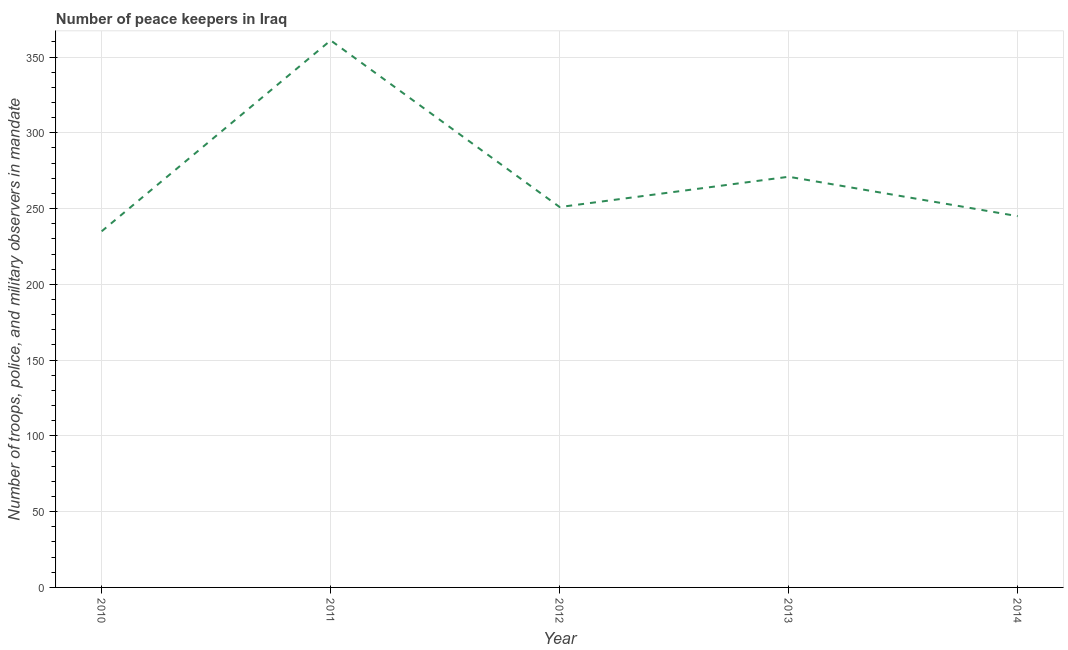What is the number of peace keepers in 2012?
Offer a terse response. 251. Across all years, what is the maximum number of peace keepers?
Give a very brief answer. 361. Across all years, what is the minimum number of peace keepers?
Give a very brief answer. 235. In which year was the number of peace keepers minimum?
Provide a succinct answer. 2010. What is the sum of the number of peace keepers?
Offer a very short reply. 1363. What is the difference between the number of peace keepers in 2011 and 2014?
Give a very brief answer. 116. What is the average number of peace keepers per year?
Your answer should be compact. 272.6. What is the median number of peace keepers?
Provide a succinct answer. 251. In how many years, is the number of peace keepers greater than 110 ?
Offer a very short reply. 5. Do a majority of the years between 2011 and 2014 (inclusive) have number of peace keepers greater than 130 ?
Your answer should be very brief. Yes. What is the ratio of the number of peace keepers in 2011 to that in 2013?
Ensure brevity in your answer.  1.33. Is the number of peace keepers in 2010 less than that in 2011?
Offer a terse response. Yes. Is the sum of the number of peace keepers in 2011 and 2013 greater than the maximum number of peace keepers across all years?
Your response must be concise. Yes. What is the difference between the highest and the lowest number of peace keepers?
Provide a succinct answer. 126. How many years are there in the graph?
Offer a very short reply. 5. Does the graph contain any zero values?
Ensure brevity in your answer.  No. Does the graph contain grids?
Offer a very short reply. Yes. What is the title of the graph?
Your answer should be very brief. Number of peace keepers in Iraq. What is the label or title of the Y-axis?
Your response must be concise. Number of troops, police, and military observers in mandate. What is the Number of troops, police, and military observers in mandate of 2010?
Offer a very short reply. 235. What is the Number of troops, police, and military observers in mandate in 2011?
Ensure brevity in your answer.  361. What is the Number of troops, police, and military observers in mandate in 2012?
Offer a terse response. 251. What is the Number of troops, police, and military observers in mandate of 2013?
Ensure brevity in your answer.  271. What is the Number of troops, police, and military observers in mandate in 2014?
Keep it short and to the point. 245. What is the difference between the Number of troops, police, and military observers in mandate in 2010 and 2011?
Provide a short and direct response. -126. What is the difference between the Number of troops, police, and military observers in mandate in 2010 and 2012?
Your answer should be compact. -16. What is the difference between the Number of troops, police, and military observers in mandate in 2010 and 2013?
Keep it short and to the point. -36. What is the difference between the Number of troops, police, and military observers in mandate in 2010 and 2014?
Your answer should be compact. -10. What is the difference between the Number of troops, police, and military observers in mandate in 2011 and 2012?
Make the answer very short. 110. What is the difference between the Number of troops, police, and military observers in mandate in 2011 and 2014?
Your response must be concise. 116. What is the difference between the Number of troops, police, and military observers in mandate in 2012 and 2013?
Provide a succinct answer. -20. What is the difference between the Number of troops, police, and military observers in mandate in 2012 and 2014?
Give a very brief answer. 6. What is the ratio of the Number of troops, police, and military observers in mandate in 2010 to that in 2011?
Keep it short and to the point. 0.65. What is the ratio of the Number of troops, police, and military observers in mandate in 2010 to that in 2012?
Your response must be concise. 0.94. What is the ratio of the Number of troops, police, and military observers in mandate in 2010 to that in 2013?
Keep it short and to the point. 0.87. What is the ratio of the Number of troops, police, and military observers in mandate in 2010 to that in 2014?
Keep it short and to the point. 0.96. What is the ratio of the Number of troops, police, and military observers in mandate in 2011 to that in 2012?
Your answer should be very brief. 1.44. What is the ratio of the Number of troops, police, and military observers in mandate in 2011 to that in 2013?
Keep it short and to the point. 1.33. What is the ratio of the Number of troops, police, and military observers in mandate in 2011 to that in 2014?
Offer a terse response. 1.47. What is the ratio of the Number of troops, police, and military observers in mandate in 2012 to that in 2013?
Your response must be concise. 0.93. What is the ratio of the Number of troops, police, and military observers in mandate in 2012 to that in 2014?
Your answer should be compact. 1.02. What is the ratio of the Number of troops, police, and military observers in mandate in 2013 to that in 2014?
Keep it short and to the point. 1.11. 